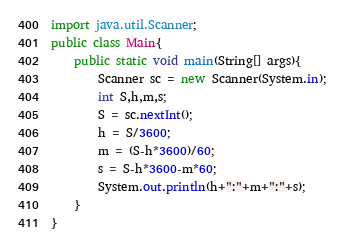Convert code to text. <code><loc_0><loc_0><loc_500><loc_500><_Java_>import java.util.Scanner;
public class Main{
	public static void main(String[] args){
		Scanner sc = new Scanner(System.in);
		int S,h,m,s;
		S = sc.nextInt();
		h = S/3600;
		m = (S-h*3600)/60;
		s = S-h*3600-m*60;
		System.out.println(h+":"+m+":"+s);
	}
}</code> 